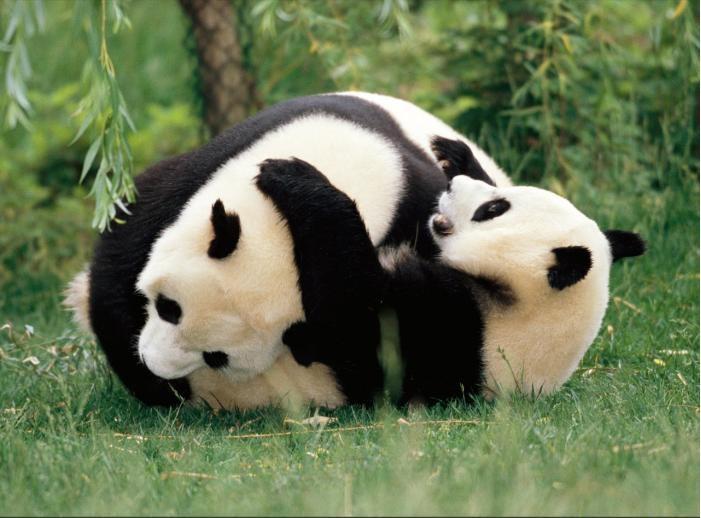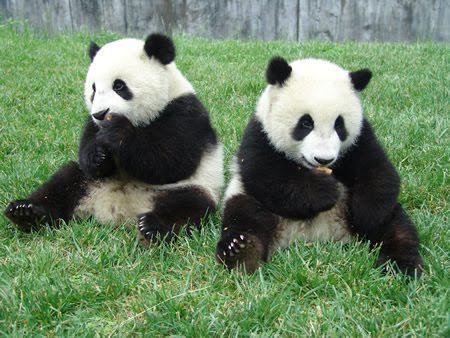The first image is the image on the left, the second image is the image on the right. Given the left and right images, does the statement "there are  exactly four pandas in one of the images" hold true? Answer yes or no. No. The first image is the image on the left, the second image is the image on the right. Considering the images on both sides, is "An image shows two pandas who appear to be playfully wrestling." valid? Answer yes or no. Yes. 